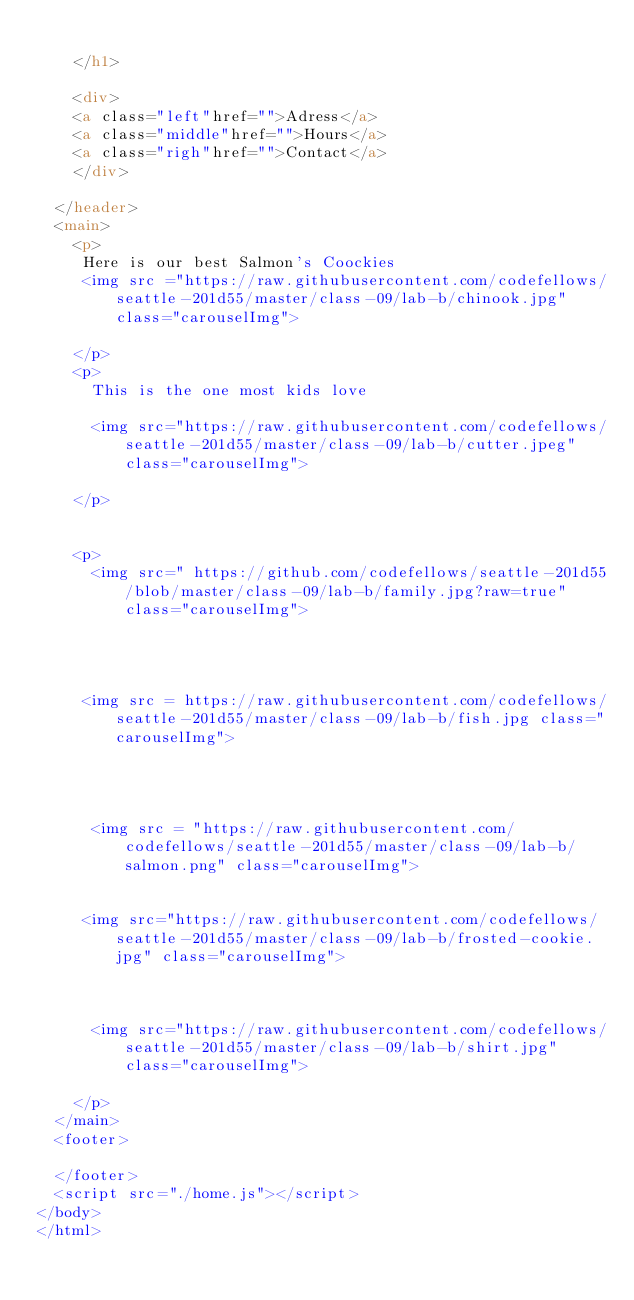<code> <loc_0><loc_0><loc_500><loc_500><_HTML_>      
    </h1>
    
    <div>
    <a class="left"href="">Adress</a>
    <a class="middle"href="">Hours</a>
    <a class="righ"href="">Contact</a>
    </div>

  </header>
  <main>
    <p>
     Here is our best Salmon's Coockies
     <img src ="https://raw.githubusercontent.com/codefellows/seattle-201d55/master/class-09/lab-b/chinook.jpg" class="carouselImg">
     
    </p>
    <p>
      This is the one most kids love 
     
      <img src="https://raw.githubusercontent.com/codefellows/seattle-201d55/master/class-09/lab-b/cutter.jpeg" class="carouselImg">

    </p>
    
  
    <p>
      <img src=" https://github.com/codefellows/seattle-201d55/blob/master/class-09/lab-b/family.jpg?raw=true" class="carouselImg">
    
    
  
    
     <img src = https://raw.githubusercontent.com/codefellows/seattle-201d55/master/class-09/lab-b/fish.jpg class="carouselImg">
  
    
    
  
      <img src = "https://raw.githubusercontent.com/codefellows/seattle-201d55/master/class-09/lab-b/salmon.png" class="carouselImg">
     
    
     <img src="https://raw.githubusercontent.com/codefellows/seattle-201d55/master/class-09/lab-b/frosted-cookie.jpg" class="carouselImg">
    
    
    
      <img src="https://raw.githubusercontent.com/codefellows/seattle-201d55/master/class-09/lab-b/shirt.jpg" class="carouselImg">
  
    </p>
  </main>
  <footer>

  </footer>
  <script src="./home.js"></script>
</body>
</html></code> 